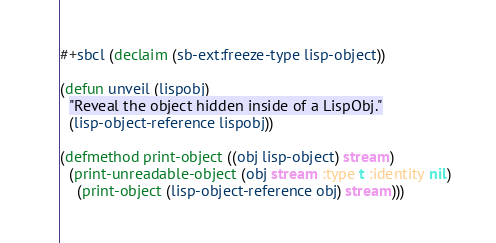<code> <loc_0><loc_0><loc_500><loc_500><_Lisp_>
#+sbcl (declaim (sb-ext:freeze-type lisp-object))

(defun unveil (lispobj)
  "Reveal the object hidden inside of a LispObj."
  (lisp-object-reference lispobj))

(defmethod print-object ((obj lisp-object) stream)
  (print-unreadable-object (obj stream :type t :identity nil)
    (print-object (lisp-object-reference obj) stream)))
</code> 